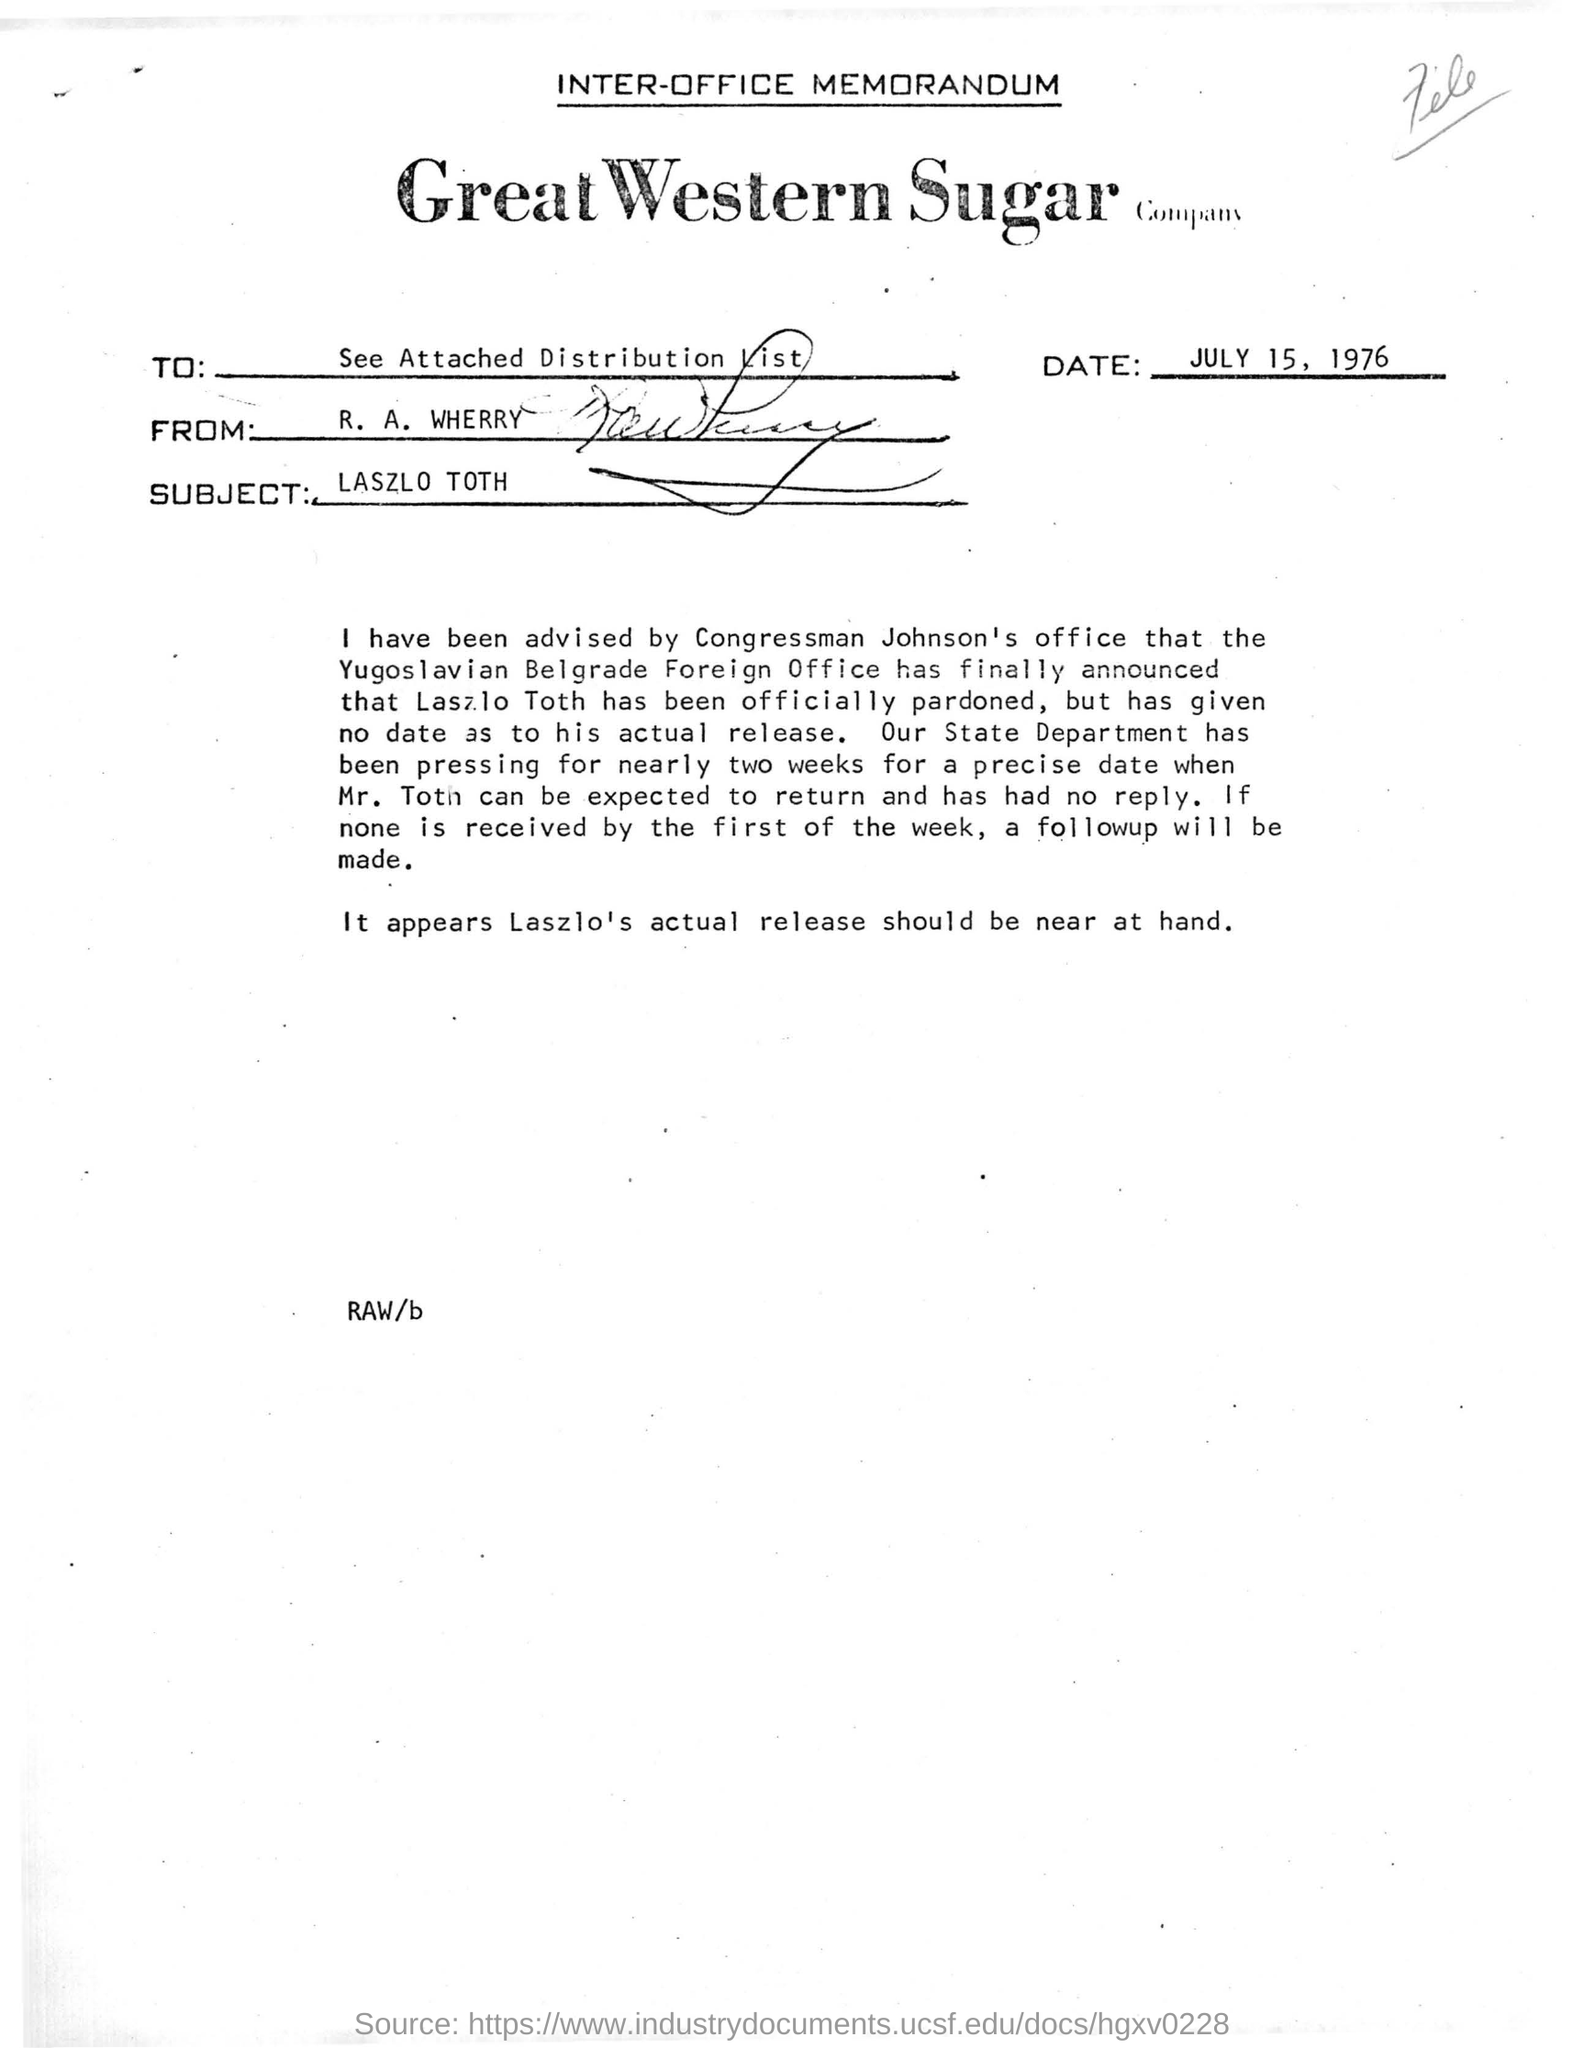Point out several critical features in this image. The Great Western Sugar Company is a well-known company that specializes in the production and distribution of sugar. This document is an inter-office memorandum. The person writing this memorandum is R. A. Wherry. The Yugoslavian Foreign Office has announced that Laszlo Toth has been officially pardoned. The subject of the inter-office memorandum is László Toth. 